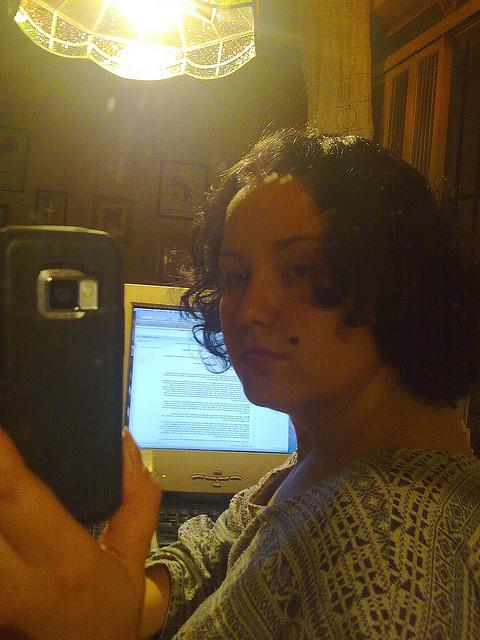What is on the woman's lip who is holding the camera in front of the computer?

Choices:
A) mole
B) lipstick
C) chapstick
D) glitter lipstick 